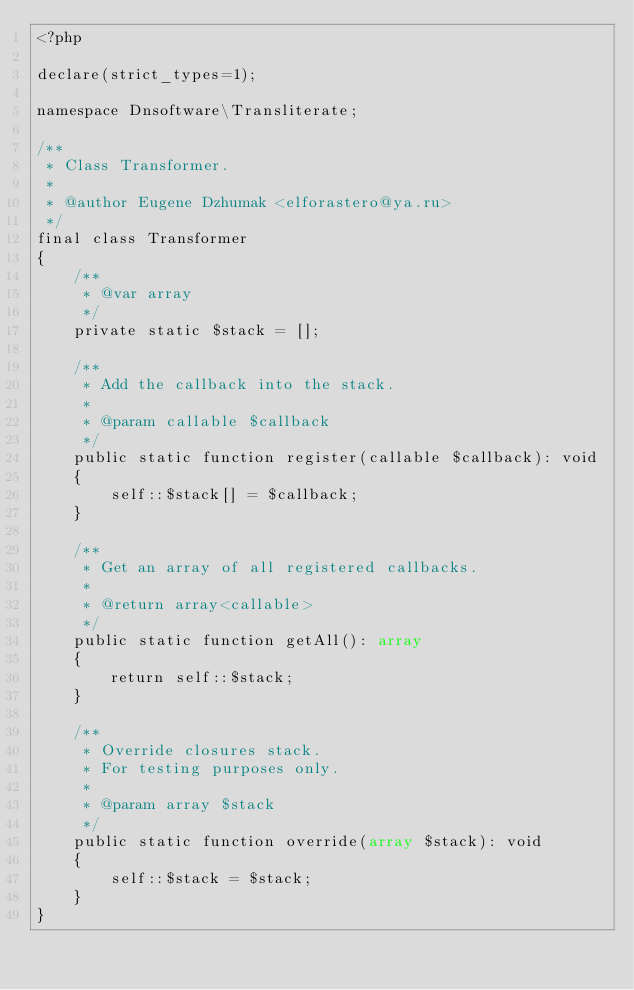<code> <loc_0><loc_0><loc_500><loc_500><_PHP_><?php

declare(strict_types=1);

namespace Dnsoftware\Transliterate;

/**
 * Class Transformer.
 *
 * @author Eugene Dzhumak <elforastero@ya.ru>
 */
final class Transformer
{
    /**
     * @var array
     */
    private static $stack = [];

    /**
     * Add the callback into the stack.
     *
     * @param callable $callback
     */
    public static function register(callable $callback): void
    {
        self::$stack[] = $callback;
    }

    /**
     * Get an array of all registered callbacks.
     *
     * @return array<callable>
     */
    public static function getAll(): array
    {
        return self::$stack;
    }

    /**
     * Override closures stack.
     * For testing purposes only.
     *
     * @param array $stack
     */
    public static function override(array $stack): void
    {
        self::$stack = $stack;
    }
}
</code> 